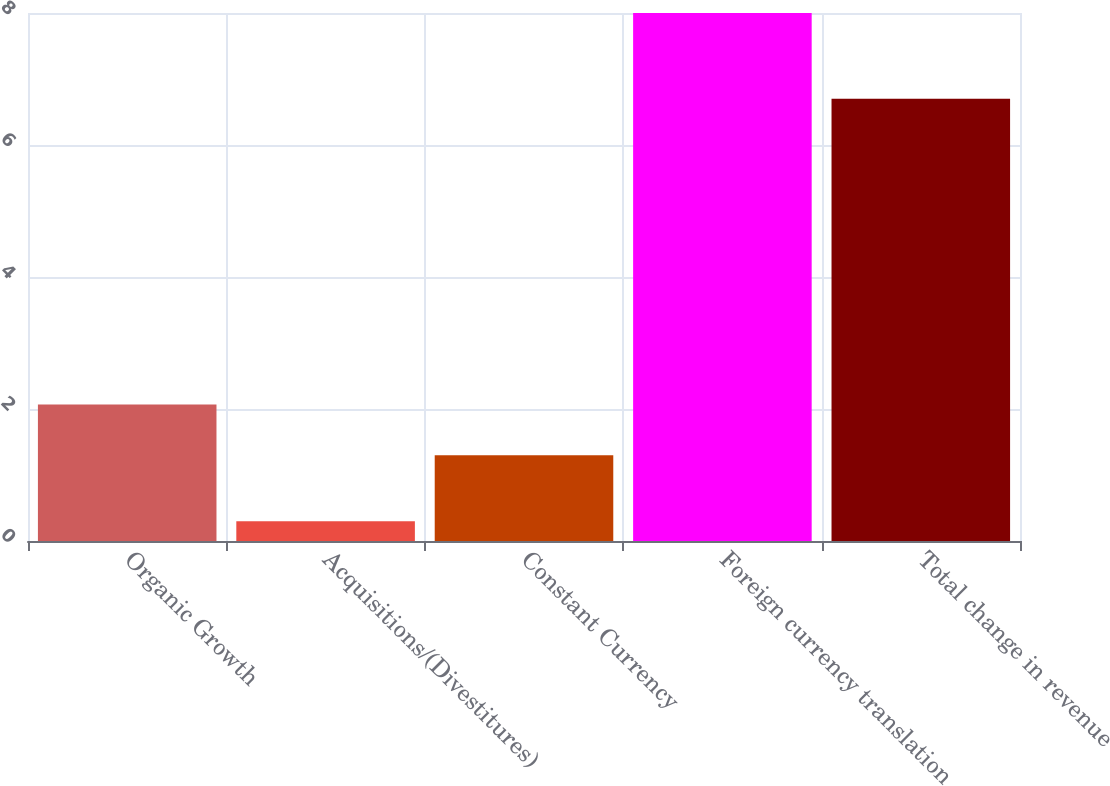Convert chart. <chart><loc_0><loc_0><loc_500><loc_500><bar_chart><fcel>Organic Growth<fcel>Acquisitions/(Divestitures)<fcel>Constant Currency<fcel>Foreign currency translation<fcel>Total change in revenue<nl><fcel>2.07<fcel>0.3<fcel>1.3<fcel>8<fcel>6.7<nl></chart> 